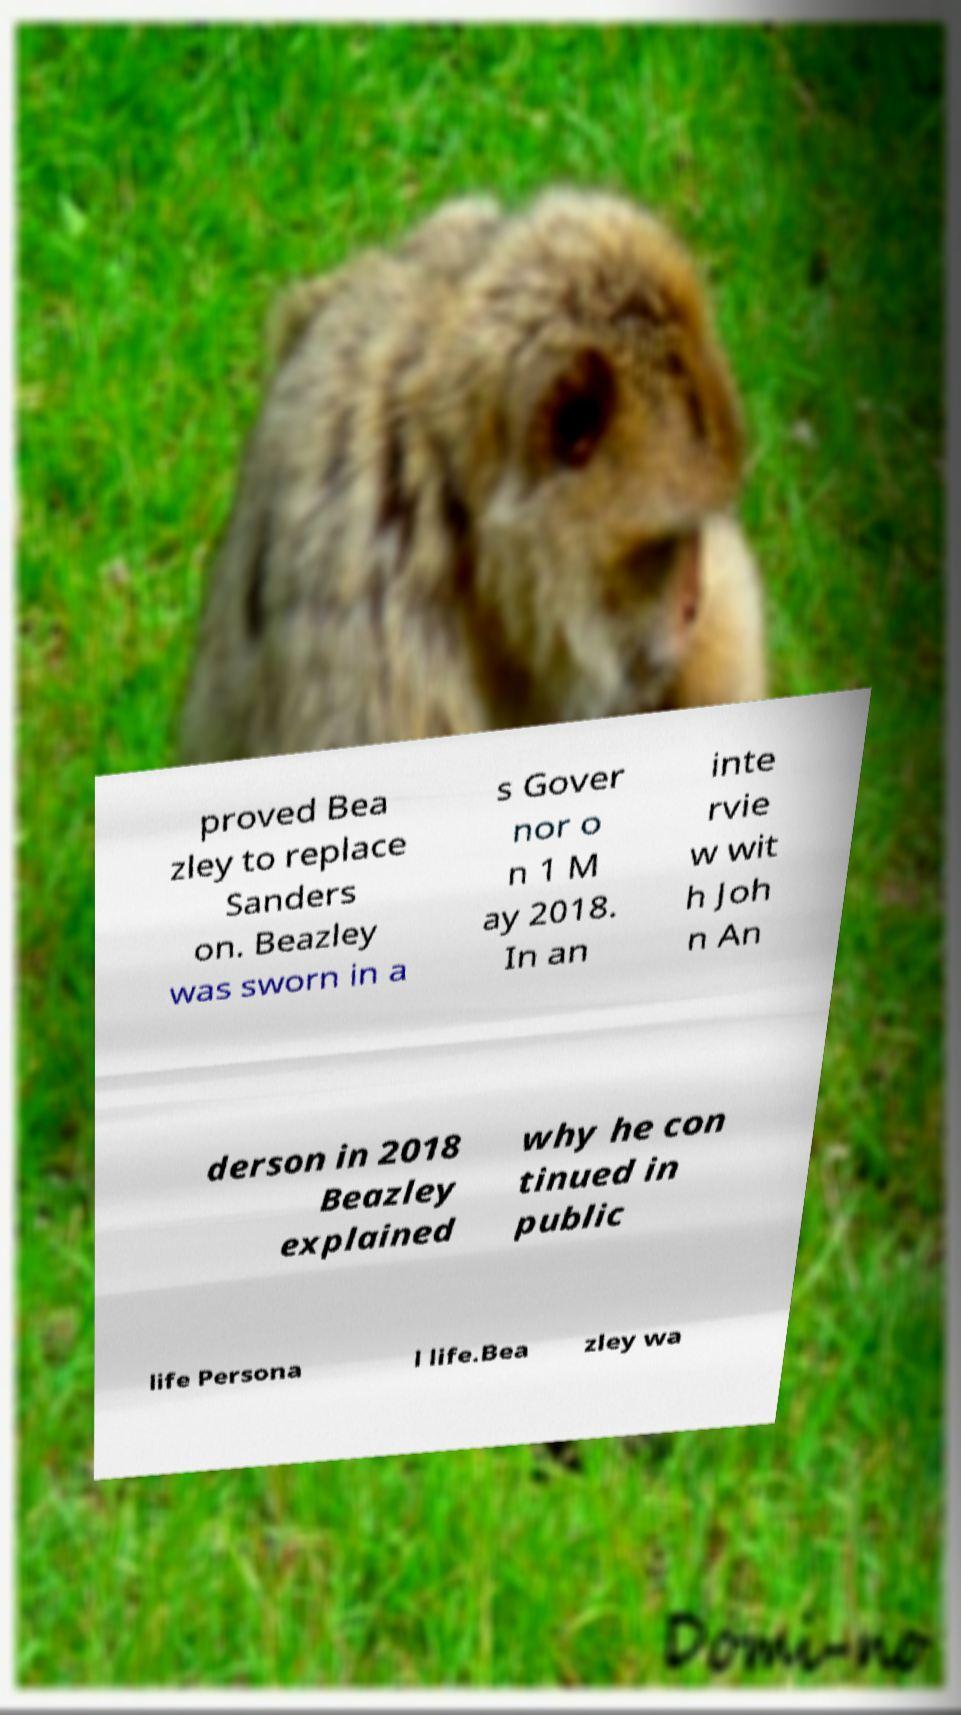What messages or text are displayed in this image? I need them in a readable, typed format. proved Bea zley to replace Sanders on. Beazley was sworn in a s Gover nor o n 1 M ay 2018. In an inte rvie w wit h Joh n An derson in 2018 Beazley explained why he con tinued in public life Persona l life.Bea zley wa 